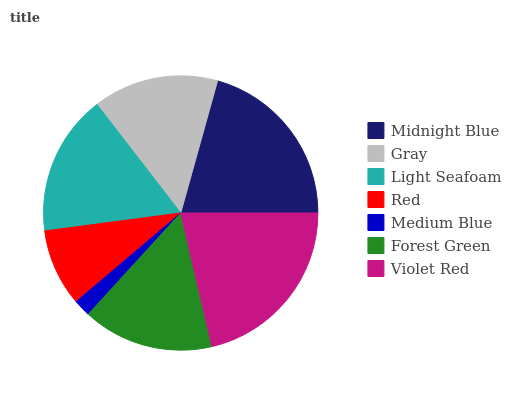Is Medium Blue the minimum?
Answer yes or no. Yes. Is Violet Red the maximum?
Answer yes or no. Yes. Is Gray the minimum?
Answer yes or no. No. Is Gray the maximum?
Answer yes or no. No. Is Midnight Blue greater than Gray?
Answer yes or no. Yes. Is Gray less than Midnight Blue?
Answer yes or no. Yes. Is Gray greater than Midnight Blue?
Answer yes or no. No. Is Midnight Blue less than Gray?
Answer yes or no. No. Is Forest Green the high median?
Answer yes or no. Yes. Is Forest Green the low median?
Answer yes or no. Yes. Is Medium Blue the high median?
Answer yes or no. No. Is Midnight Blue the low median?
Answer yes or no. No. 